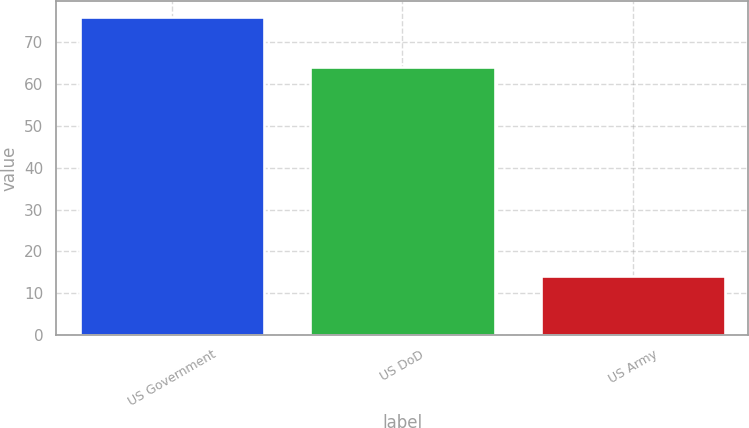Convert chart to OTSL. <chart><loc_0><loc_0><loc_500><loc_500><bar_chart><fcel>US Government<fcel>US DoD<fcel>US Army<nl><fcel>76<fcel>64<fcel>14<nl></chart> 